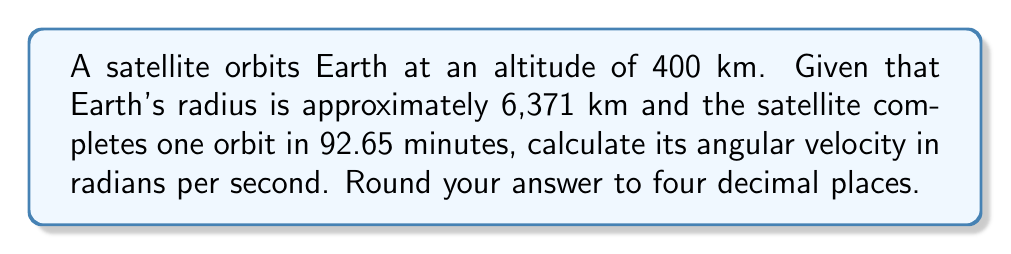Give your solution to this math problem. Let's approach this step-by-step:

1) First, we need to understand that angular velocity (ω) is given by the formula:

   $$ω = \frac{2π}{T}$$

   where T is the period of orbit in seconds.

2) We're given the period in minutes, so let's convert it to seconds:
   
   $$T = 92.65 \text{ minutes} \times 60 \text{ seconds/minute} = 5559 \text{ seconds}$$

3) Now we can plug this into our formula:

   $$ω = \frac{2π}{5559}$$

4) Let's calculate this:

   $$ω = \frac{2 \times 3.14159...}{5559} \approx 0.001130 \text{ radians/second}$$

5) Rounding to four decimal places:

   $$ω \approx 0.0011 \text{ radians/second}$$

As a former astronaut, you'd appreciate the precision required in these calculations. The angular velocity is crucial for maintaining proper orbit and for planning maneuvers in space.
Answer: 0.0011 rad/s 